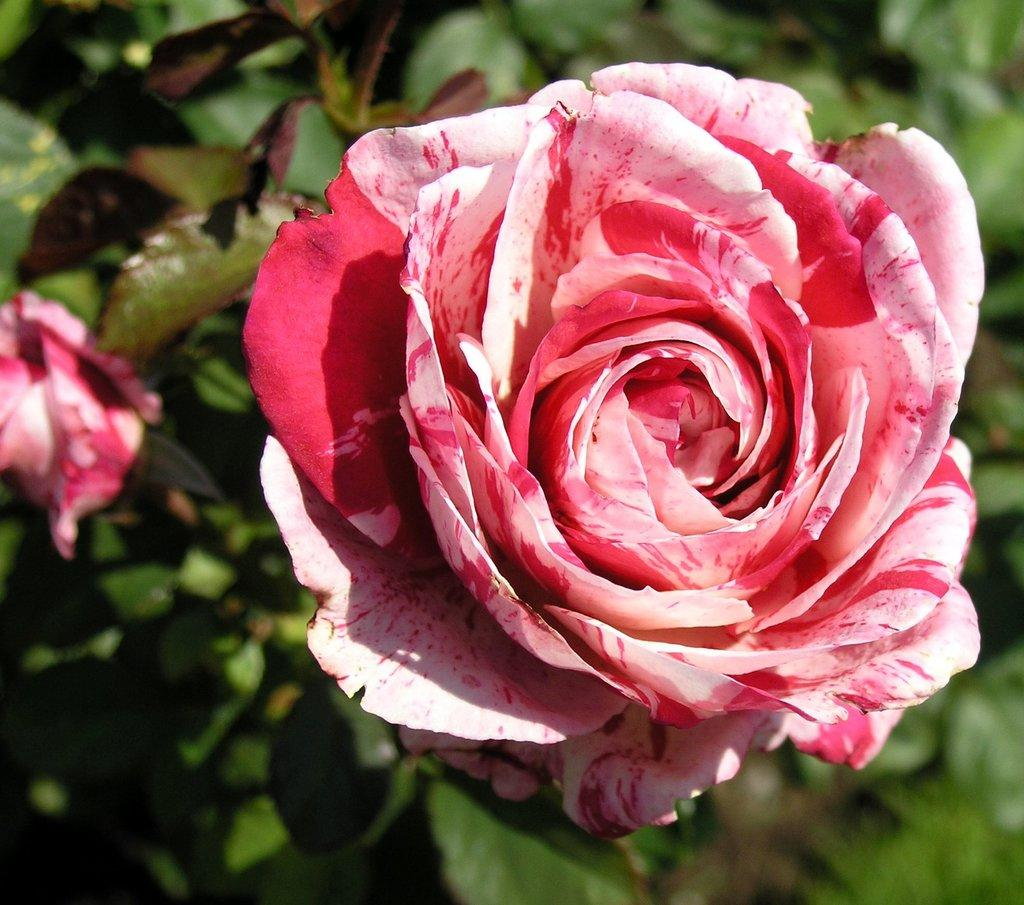What is present in the image? There is a plant in the image. How many flowers are on the plant? The plant has two flowers. Can you describe the background of the image? The background of the image is blurred. What type of food is being served on the chair in the image? There is no chair or food present in the image; it only features a plant with two flowers and a blurred background. 